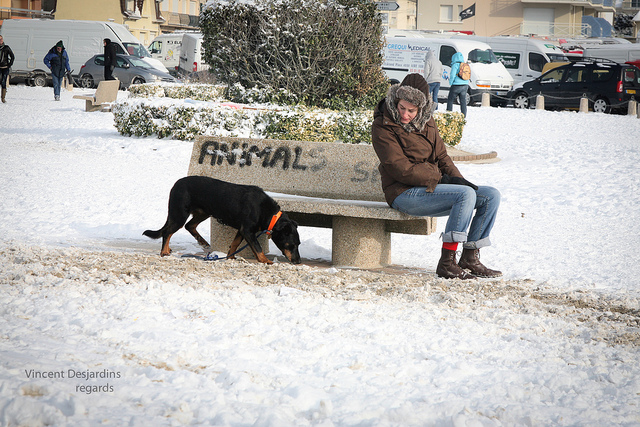<image>What breed is the dog? I am not sure about the breed of the dog. It could possibly be a Rottweiler, German Shepherd, Black Lab, Doberman, or a mixed breed. What breed is the dog? The breed of the dog is not clear. It can be seen as 'rottweiler', 'german shepherd', 'black lab', 'mixed breed', 'doberman', 'mutt', 'not sure' or 'doberman'. 